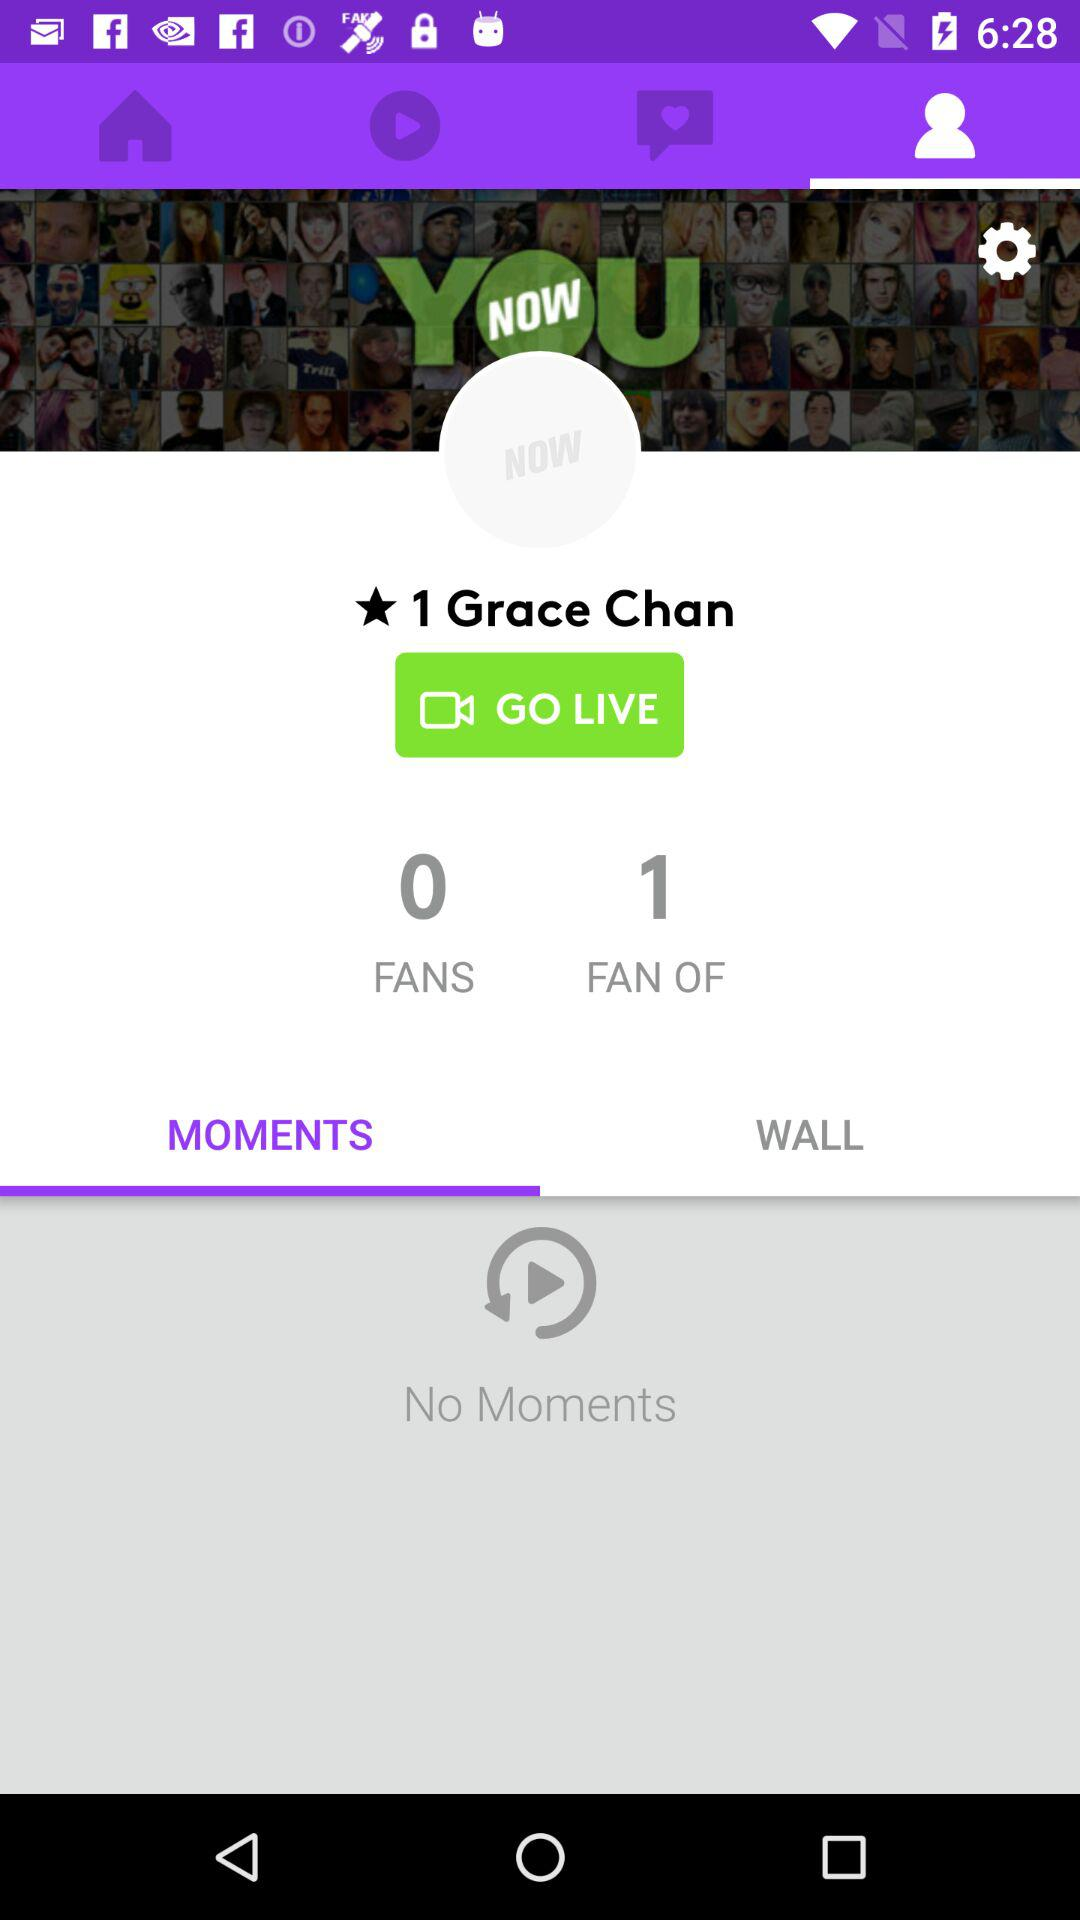What is the name of the user? The name of the user is Grace Chan. 